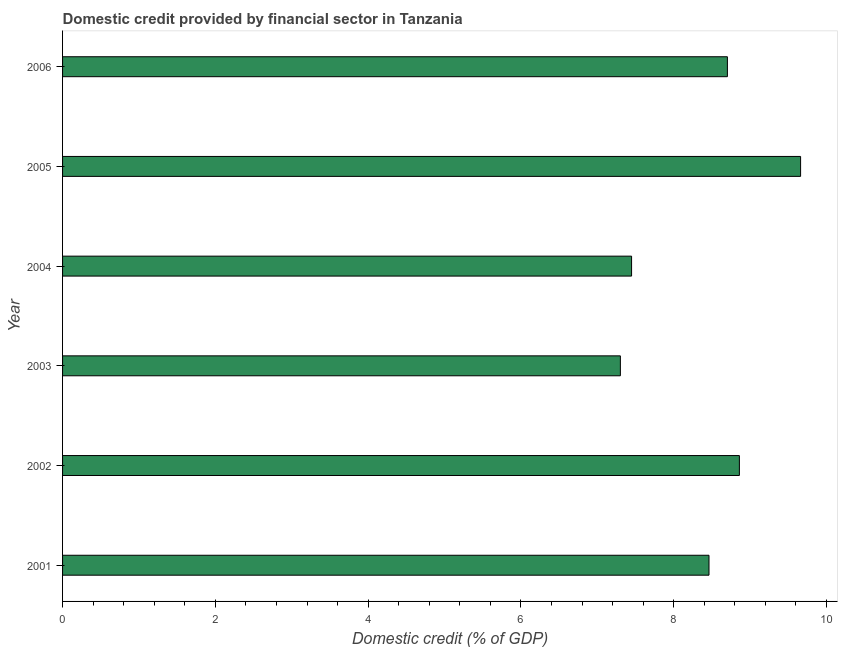Does the graph contain any zero values?
Offer a terse response. No. Does the graph contain grids?
Keep it short and to the point. No. What is the title of the graph?
Your response must be concise. Domestic credit provided by financial sector in Tanzania. What is the label or title of the X-axis?
Make the answer very short. Domestic credit (% of GDP). What is the label or title of the Y-axis?
Your answer should be very brief. Year. What is the domestic credit provided by financial sector in 2004?
Provide a succinct answer. 7.45. Across all years, what is the maximum domestic credit provided by financial sector?
Your answer should be very brief. 9.66. Across all years, what is the minimum domestic credit provided by financial sector?
Keep it short and to the point. 7.3. In which year was the domestic credit provided by financial sector maximum?
Offer a terse response. 2005. What is the sum of the domestic credit provided by financial sector?
Make the answer very short. 50.43. What is the difference between the domestic credit provided by financial sector in 2001 and 2006?
Your answer should be very brief. -0.24. What is the average domestic credit provided by financial sector per year?
Make the answer very short. 8.4. What is the median domestic credit provided by financial sector?
Your answer should be very brief. 8.58. Do a majority of the years between 2006 and 2005 (inclusive) have domestic credit provided by financial sector greater than 8.4 %?
Offer a terse response. No. Is the domestic credit provided by financial sector in 2001 less than that in 2006?
Provide a succinct answer. Yes. Is the difference between the domestic credit provided by financial sector in 2002 and 2006 greater than the difference between any two years?
Make the answer very short. No. What is the difference between the highest and the second highest domestic credit provided by financial sector?
Your answer should be compact. 0.8. Is the sum of the domestic credit provided by financial sector in 2005 and 2006 greater than the maximum domestic credit provided by financial sector across all years?
Offer a very short reply. Yes. What is the difference between the highest and the lowest domestic credit provided by financial sector?
Your answer should be very brief. 2.36. Are all the bars in the graph horizontal?
Give a very brief answer. Yes. What is the difference between two consecutive major ticks on the X-axis?
Your answer should be very brief. 2. Are the values on the major ticks of X-axis written in scientific E-notation?
Ensure brevity in your answer.  No. What is the Domestic credit (% of GDP) of 2001?
Offer a very short reply. 8.46. What is the Domestic credit (% of GDP) in 2002?
Provide a short and direct response. 8.86. What is the Domestic credit (% of GDP) in 2003?
Your answer should be very brief. 7.3. What is the Domestic credit (% of GDP) in 2004?
Provide a succinct answer. 7.45. What is the Domestic credit (% of GDP) in 2005?
Provide a succinct answer. 9.66. What is the Domestic credit (% of GDP) of 2006?
Keep it short and to the point. 8.7. What is the difference between the Domestic credit (% of GDP) in 2001 and 2002?
Make the answer very short. -0.4. What is the difference between the Domestic credit (% of GDP) in 2001 and 2003?
Keep it short and to the point. 1.16. What is the difference between the Domestic credit (% of GDP) in 2001 and 2004?
Provide a short and direct response. 1.01. What is the difference between the Domestic credit (% of GDP) in 2001 and 2005?
Keep it short and to the point. -1.2. What is the difference between the Domestic credit (% of GDP) in 2001 and 2006?
Offer a terse response. -0.24. What is the difference between the Domestic credit (% of GDP) in 2002 and 2003?
Give a very brief answer. 1.56. What is the difference between the Domestic credit (% of GDP) in 2002 and 2004?
Give a very brief answer. 1.41. What is the difference between the Domestic credit (% of GDP) in 2002 and 2005?
Offer a very short reply. -0.8. What is the difference between the Domestic credit (% of GDP) in 2002 and 2006?
Give a very brief answer. 0.16. What is the difference between the Domestic credit (% of GDP) in 2003 and 2004?
Your response must be concise. -0.15. What is the difference between the Domestic credit (% of GDP) in 2003 and 2005?
Ensure brevity in your answer.  -2.36. What is the difference between the Domestic credit (% of GDP) in 2003 and 2006?
Your answer should be compact. -1.4. What is the difference between the Domestic credit (% of GDP) in 2004 and 2005?
Your answer should be compact. -2.21. What is the difference between the Domestic credit (% of GDP) in 2004 and 2006?
Offer a very short reply. -1.25. What is the difference between the Domestic credit (% of GDP) in 2005 and 2006?
Your answer should be compact. 0.96. What is the ratio of the Domestic credit (% of GDP) in 2001 to that in 2002?
Ensure brevity in your answer.  0.95. What is the ratio of the Domestic credit (% of GDP) in 2001 to that in 2003?
Provide a succinct answer. 1.16. What is the ratio of the Domestic credit (% of GDP) in 2001 to that in 2004?
Keep it short and to the point. 1.14. What is the ratio of the Domestic credit (% of GDP) in 2001 to that in 2005?
Give a very brief answer. 0.88. What is the ratio of the Domestic credit (% of GDP) in 2001 to that in 2006?
Make the answer very short. 0.97. What is the ratio of the Domestic credit (% of GDP) in 2002 to that in 2003?
Your answer should be very brief. 1.21. What is the ratio of the Domestic credit (% of GDP) in 2002 to that in 2004?
Ensure brevity in your answer.  1.19. What is the ratio of the Domestic credit (% of GDP) in 2002 to that in 2005?
Your response must be concise. 0.92. What is the ratio of the Domestic credit (% of GDP) in 2002 to that in 2006?
Your answer should be compact. 1.02. What is the ratio of the Domestic credit (% of GDP) in 2003 to that in 2004?
Provide a succinct answer. 0.98. What is the ratio of the Domestic credit (% of GDP) in 2003 to that in 2005?
Your answer should be compact. 0.76. What is the ratio of the Domestic credit (% of GDP) in 2003 to that in 2006?
Your response must be concise. 0.84. What is the ratio of the Domestic credit (% of GDP) in 2004 to that in 2005?
Make the answer very short. 0.77. What is the ratio of the Domestic credit (% of GDP) in 2004 to that in 2006?
Offer a very short reply. 0.86. What is the ratio of the Domestic credit (% of GDP) in 2005 to that in 2006?
Offer a very short reply. 1.11. 